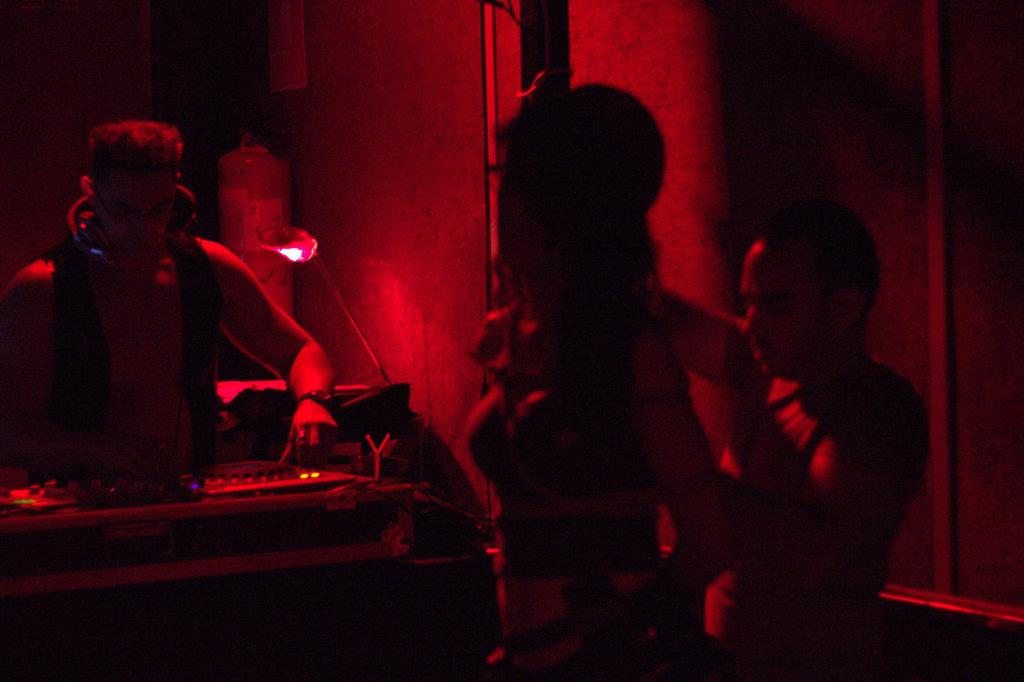Who or what can be seen in the image? There are people in the image. What is the purpose of the music system in the image? The music system in the image is likely used for playing music. What is the background of the image? There is a wall in the image. Can you describe any other objects in the image? There are some other objects in the image, but their specific details are not mentioned in the provided facts. What type of clam is being used as a decorative item in the image? There is no clam present in the image; it only features people, a music system, and a wall. 